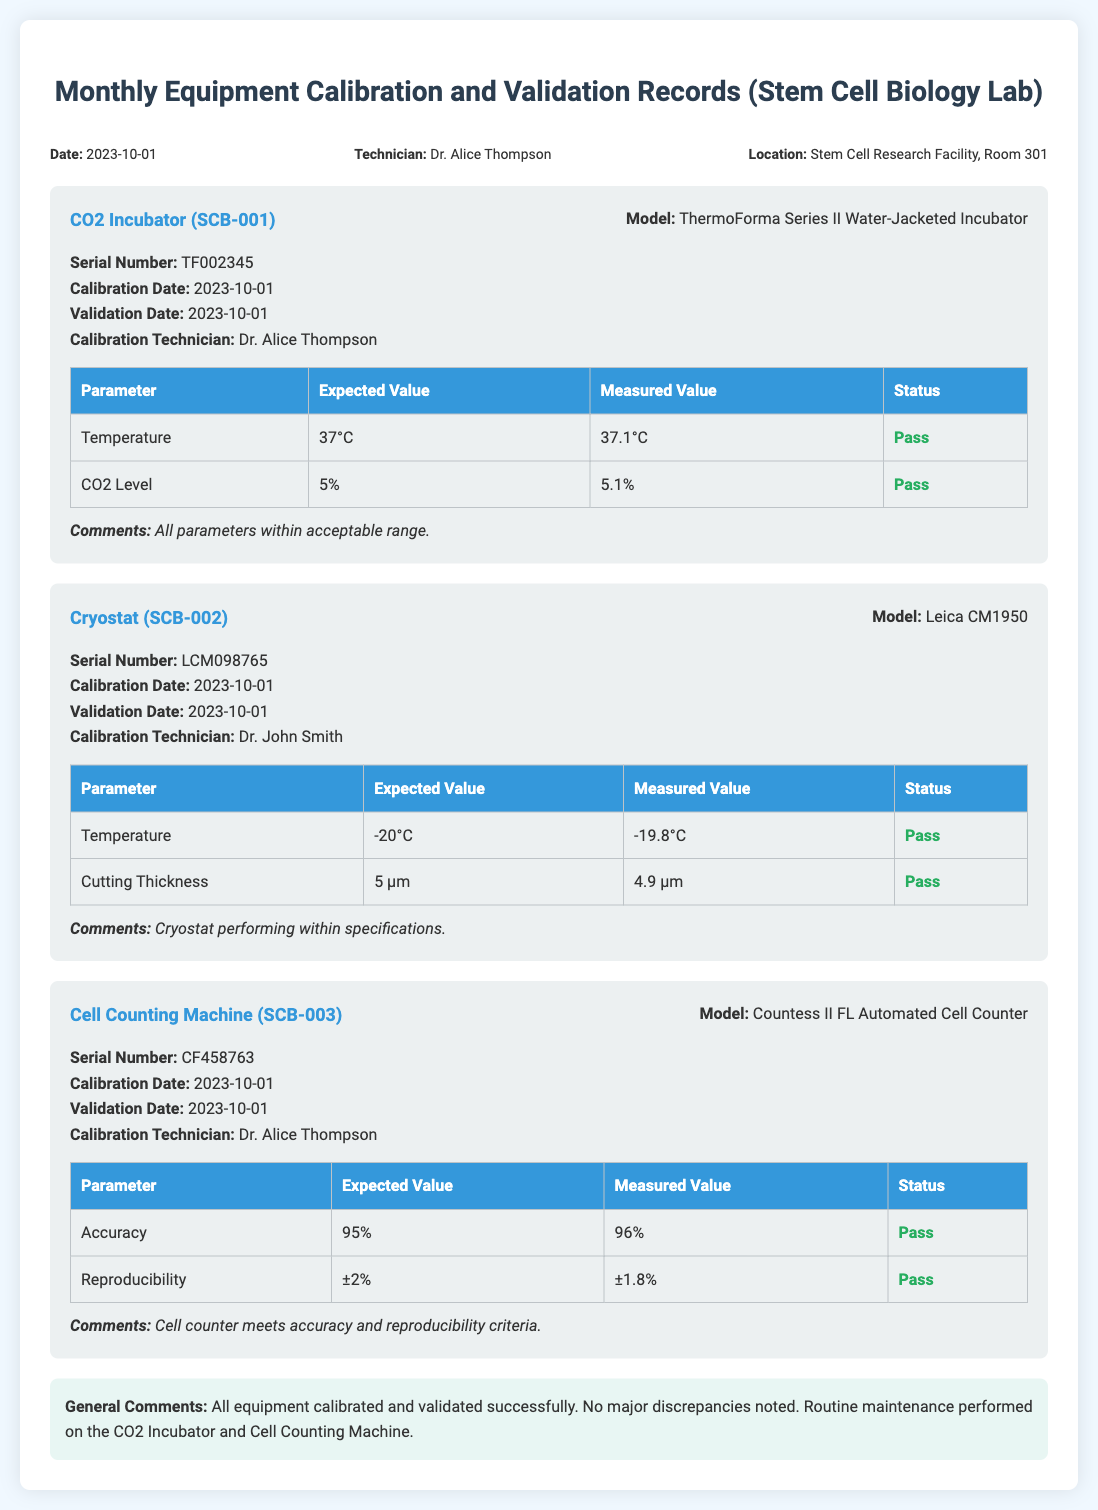What is the date of the calibration? The date of calibration is specified in the header information of the document.
Answer: 2023-10-01 Who performed the calibration for the CO2 Incubator? The calibration technician's name for the CO2 Incubator is listed under its details.
Answer: Dr. Alice Thompson What is the serial number of the Cryostat? The serial number for the Cryostat is indicated in its equipment details.
Answer: LCM098765 What parameter was measured for the Cell Counting Machine related to accuracy? The measured parameter for accuracy is specified in the table of the Cell Counting Machine equipment.
Answer: 96% What is the expected value for the CO2 Level? The expected value for the CO2 Level is presented in the calibration details of the CO2 Incubator.
Answer: 5% How many equipment items were calibrated in this document? The number of equipment items can be determined by counting the sections of equipment logged in the document.
Answer: 3 What is the status of the Cutting Thickness measurement for the Cryostat? The status for Cutting Thickness is found in the table under the Cryostat's details.
Answer: Pass What are the general comments on the equipment calibration? General comments summarize the overall results found at the end of the document.
Answer: All equipment calibrated and validated successfully Who is the technician for the Cell Counting Machine calibration? The technician's name for the calibration of the Cell Counting Machine is mentioned in its details.
Answer: Dr. Alice Thompson 